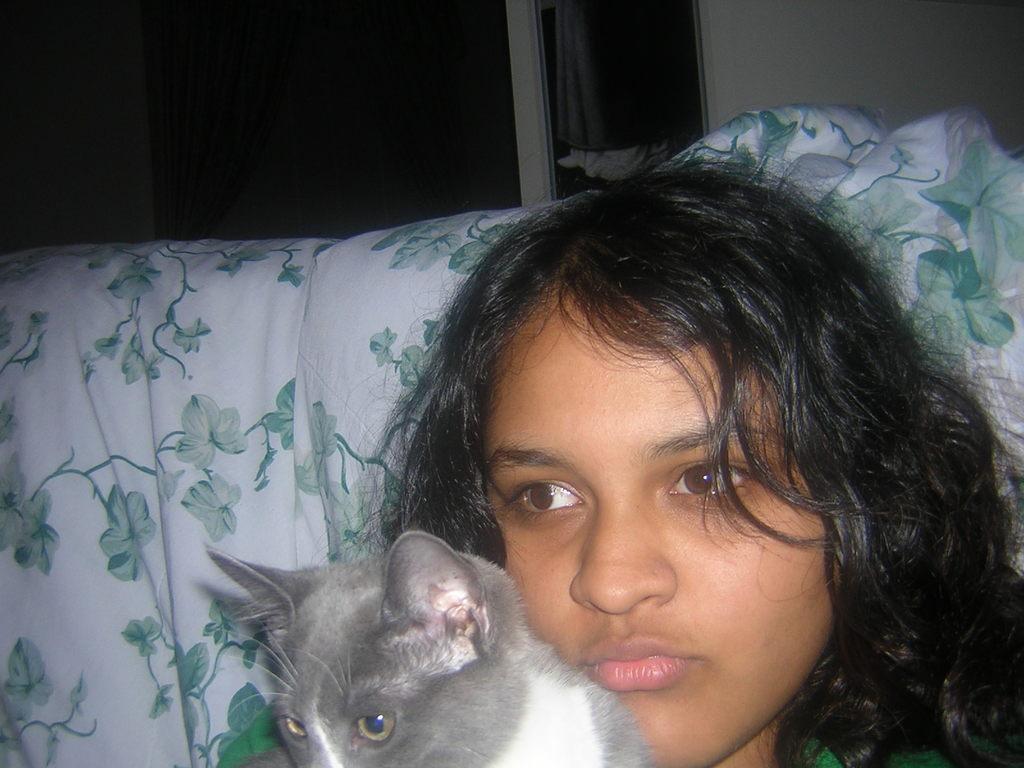Can you describe this image briefly? In the picture we can see a girl and holding a cat. In the background we can find a pillow, curtain and a window with wall. 